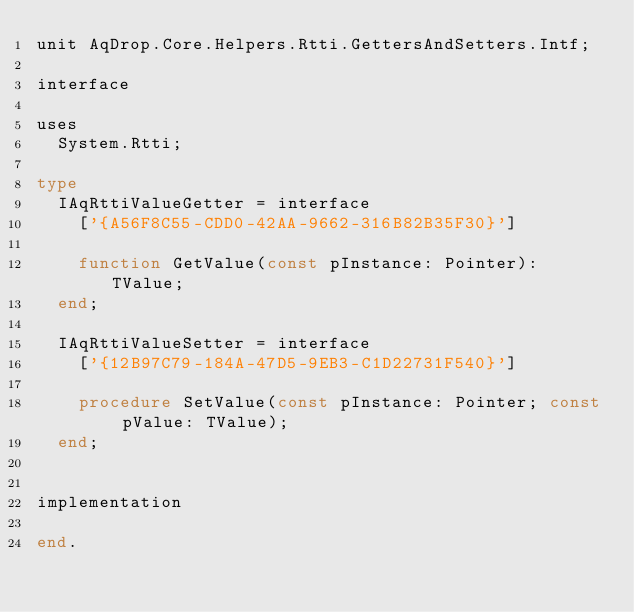<code> <loc_0><loc_0><loc_500><loc_500><_Pascal_>unit AqDrop.Core.Helpers.Rtti.GettersAndSetters.Intf;

interface

uses
  System.Rtti;

type
  IAqRttiValueGetter = interface
    ['{A56F8C55-CDD0-42AA-9662-316B82B35F30}']

    function GetValue(const pInstance: Pointer): TValue;
  end;

  IAqRttiValueSetter = interface
    ['{12B97C79-184A-47D5-9EB3-C1D22731F540}']

    procedure SetValue(const pInstance: Pointer; const pValue: TValue);
  end;


implementation

end.
</code> 